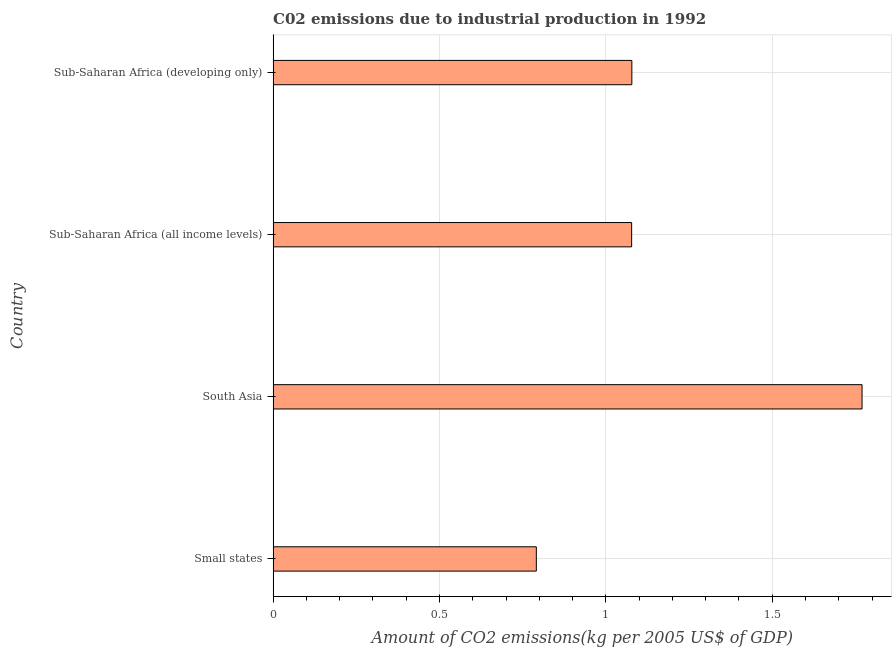What is the title of the graph?
Your answer should be compact. C02 emissions due to industrial production in 1992. What is the label or title of the X-axis?
Make the answer very short. Amount of CO2 emissions(kg per 2005 US$ of GDP). What is the label or title of the Y-axis?
Your answer should be compact. Country. What is the amount of co2 emissions in Small states?
Your response must be concise. 0.79. Across all countries, what is the maximum amount of co2 emissions?
Your answer should be very brief. 1.77. Across all countries, what is the minimum amount of co2 emissions?
Offer a terse response. 0.79. In which country was the amount of co2 emissions maximum?
Keep it short and to the point. South Asia. In which country was the amount of co2 emissions minimum?
Keep it short and to the point. Small states. What is the sum of the amount of co2 emissions?
Offer a terse response. 4.72. What is the difference between the amount of co2 emissions in Sub-Saharan Africa (all income levels) and Sub-Saharan Africa (developing only)?
Ensure brevity in your answer.  -0. What is the average amount of co2 emissions per country?
Your response must be concise. 1.18. What is the median amount of co2 emissions?
Your answer should be very brief. 1.08. What is the ratio of the amount of co2 emissions in South Asia to that in Sub-Saharan Africa (all income levels)?
Provide a short and direct response. 1.64. Is the amount of co2 emissions in Small states less than that in South Asia?
Offer a very short reply. Yes. Is the difference between the amount of co2 emissions in Small states and Sub-Saharan Africa (all income levels) greater than the difference between any two countries?
Make the answer very short. No. What is the difference between the highest and the second highest amount of co2 emissions?
Make the answer very short. 0.69. What is the difference between the highest and the lowest amount of co2 emissions?
Make the answer very short. 0.98. In how many countries, is the amount of co2 emissions greater than the average amount of co2 emissions taken over all countries?
Your response must be concise. 1. How many bars are there?
Ensure brevity in your answer.  4. Are all the bars in the graph horizontal?
Provide a short and direct response. Yes. How many countries are there in the graph?
Your answer should be compact. 4. What is the difference between two consecutive major ticks on the X-axis?
Your answer should be compact. 0.5. What is the Amount of CO2 emissions(kg per 2005 US$ of GDP) of Small states?
Keep it short and to the point. 0.79. What is the Amount of CO2 emissions(kg per 2005 US$ of GDP) of South Asia?
Keep it short and to the point. 1.77. What is the Amount of CO2 emissions(kg per 2005 US$ of GDP) of Sub-Saharan Africa (all income levels)?
Offer a terse response. 1.08. What is the Amount of CO2 emissions(kg per 2005 US$ of GDP) of Sub-Saharan Africa (developing only)?
Your answer should be very brief. 1.08. What is the difference between the Amount of CO2 emissions(kg per 2005 US$ of GDP) in Small states and South Asia?
Make the answer very short. -0.98. What is the difference between the Amount of CO2 emissions(kg per 2005 US$ of GDP) in Small states and Sub-Saharan Africa (all income levels)?
Offer a very short reply. -0.29. What is the difference between the Amount of CO2 emissions(kg per 2005 US$ of GDP) in Small states and Sub-Saharan Africa (developing only)?
Provide a succinct answer. -0.29. What is the difference between the Amount of CO2 emissions(kg per 2005 US$ of GDP) in South Asia and Sub-Saharan Africa (all income levels)?
Your answer should be compact. 0.69. What is the difference between the Amount of CO2 emissions(kg per 2005 US$ of GDP) in South Asia and Sub-Saharan Africa (developing only)?
Provide a short and direct response. 0.69. What is the difference between the Amount of CO2 emissions(kg per 2005 US$ of GDP) in Sub-Saharan Africa (all income levels) and Sub-Saharan Africa (developing only)?
Give a very brief answer. -0. What is the ratio of the Amount of CO2 emissions(kg per 2005 US$ of GDP) in Small states to that in South Asia?
Keep it short and to the point. 0.45. What is the ratio of the Amount of CO2 emissions(kg per 2005 US$ of GDP) in Small states to that in Sub-Saharan Africa (all income levels)?
Your answer should be very brief. 0.73. What is the ratio of the Amount of CO2 emissions(kg per 2005 US$ of GDP) in Small states to that in Sub-Saharan Africa (developing only)?
Your response must be concise. 0.73. What is the ratio of the Amount of CO2 emissions(kg per 2005 US$ of GDP) in South Asia to that in Sub-Saharan Africa (all income levels)?
Provide a short and direct response. 1.64. What is the ratio of the Amount of CO2 emissions(kg per 2005 US$ of GDP) in South Asia to that in Sub-Saharan Africa (developing only)?
Your response must be concise. 1.64. 